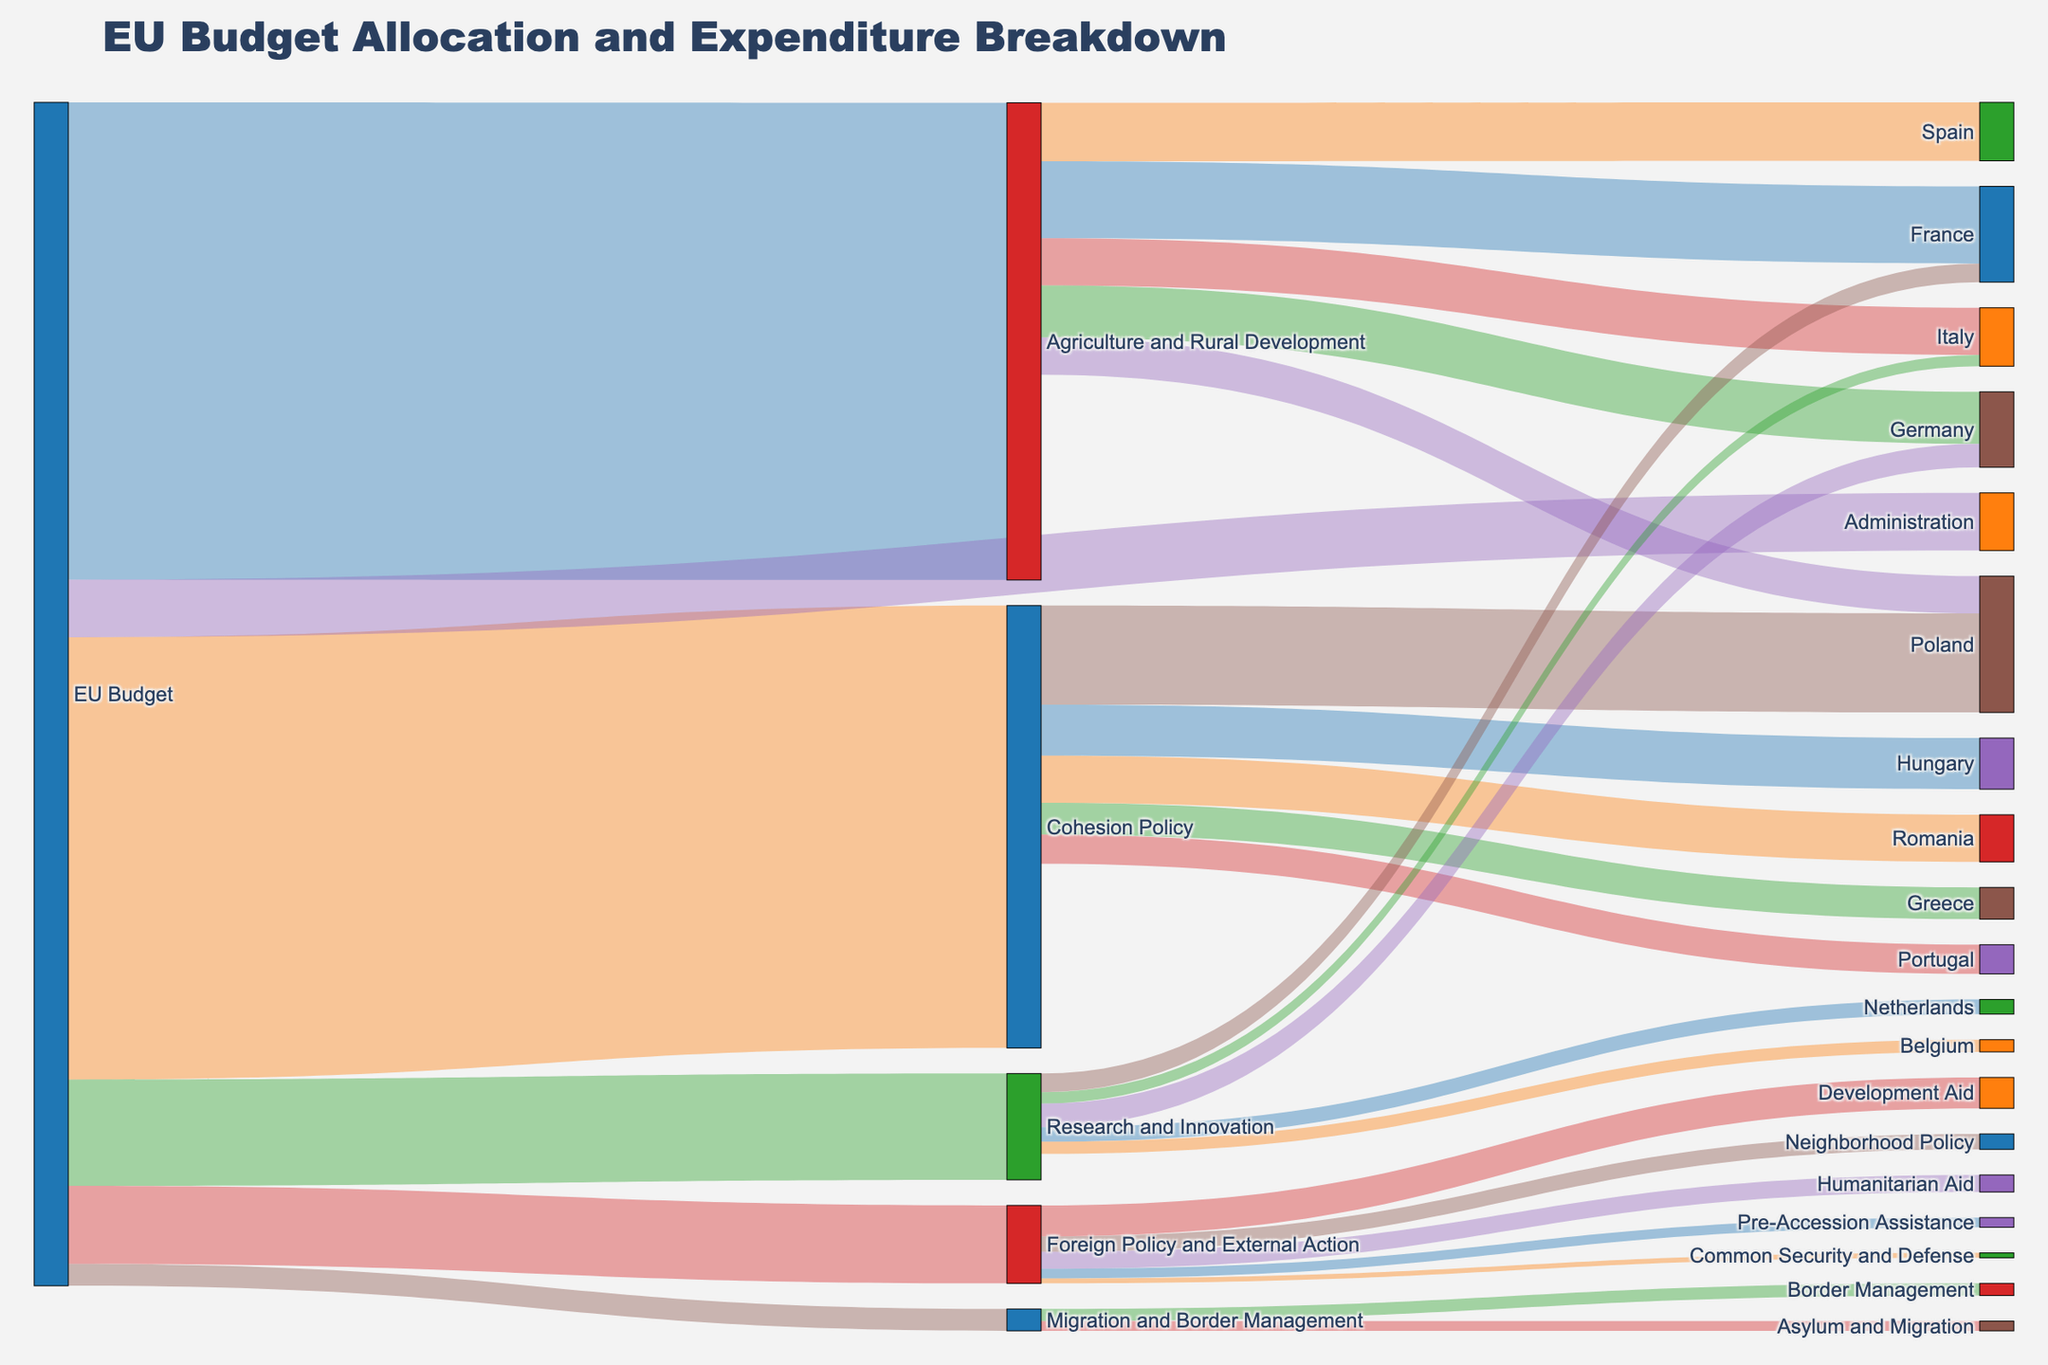What is the total allocation for Agriculture and Rural Development? According to the figure, Agriculture and Rural Development has allocations from the EU Budget totaling 58.8 units. This is directly visible as a connection from the EU Budget to Agriculture and Rural Development.
Answer: 58.8 Which member state receives the highest allocation in the category of Cohesion Policy? The figure shows several member states receiving allocations under Cohesion Policy, but Poland has the highest allocation of 12.2 units, which is the highest among the listed states for this category.
Answer: Poland Compare the allocations for Research and Innovation received by Germany and the Netherlands. Which country receives more, and by how much? The allocations under Research and Innovation are given as Germany (2.9 units) and the Netherlands (1.8 units). The difference is calculated as 2.9 - 1.8 = 1.1 units, meaning Germany receives more.
Answer: Germany, 1.1 What is the combined allocation for Asylum and Migration and Border Management within Migration and Border Management? Migration and Border Management consists of allocations to Border Management (1.5 units) and Asylum and Migration (1.2 units). Adding these, 1.5 + 1.2 = 2.7 units.
Answer: 2.7 Among the different sectors, which one features the smallest individual allocations, and what are they? In Foreign Policy and External Action, the smallest individual allocations are Common Security and Defense (0.6 units) and Pre-Accession Assistance (1.2 units). This can be observed directly from the diagram as the smallest flows.
Answer: Common Security and Defense, Pre-Accession Assistance What percentage of the total EU Budget is allocated to Foreign Policy and External Action? The total EU Budget allocation to Foreign Policy and External Action is 9.6 units. The overall EU Budget amounts to 146.2 units (sum of all allocations). Therefore, the percentage is calculated as (9.6/146.2) * 100 ≈ 6.56%.
Answer: 6.56% Identify the target that receives the largest allocation within Foreign Policy and External Action. In Foreign Policy and External Action, the largest allocation goes to Development Aid, which receives 3.8 units, as it is the thickest flow in this section.
Answer: Development Aid If we combine the allocations received by France from the EU Budget directly and indirectly, what is the total amount? France receives allocations directly in Agriculture and Rural Development (9.5 units) and in Research and Innovation (2.3 units). Combining these, 9.5 + 2.3 = 11.8 units.
Answer: 11.8 How does the allocation for Administration compare with that for Migration and Border Management? Administration receives 7.1 units from the EU Budget, while Migration and Border Management receives 2.7 units. Administration, therefore, receives 7.1 - 2.7 = 4.4 units more.
Answer: Administration, 4.4 